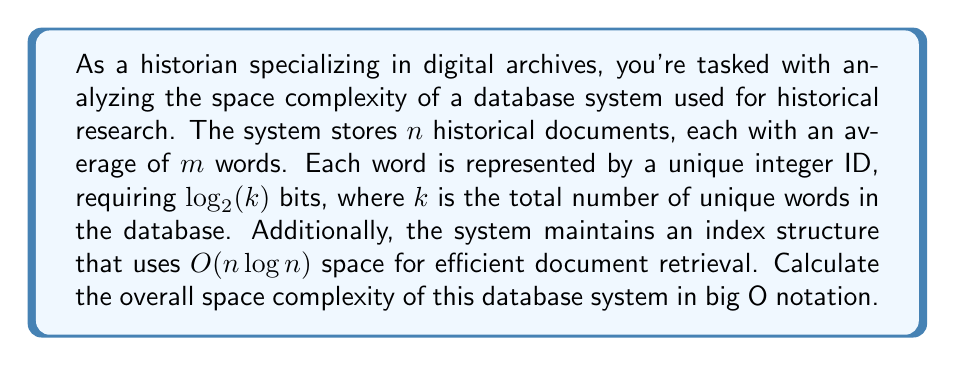Can you solve this math problem? Let's break down the space complexity analysis step by step:

1) Storage for documents:
   - Number of documents: $n$
   - Average words per document: $m$
   - Bits per word: $\log_2(k)$
   - Total space for documents: $O(n \cdot m \cdot \log_2(k))$

2) Index structure:
   - Space complexity: $O(n \log n)$

3) Combining the space requirements:
   The total space complexity is the sum of document storage and index structure:
   $$O(n \cdot m \cdot \log_2(k) + n \log n)$$

4) Simplifying the expression:
   - Since $m$ and $k$ are typically much smaller than $n$ in large databases, we can consider them as constants.
   - $\log_2(k)$ is also typically much smaller than $\log n$ for large $n$.
   
5) Final simplification:
   The dominant term will be $n \log n$, so we can express the overall space complexity as:
   $$O(n \log n)$$

This represents the asymptotic upper bound on the space required by the database system as the number of documents ($n$) grows large.
Answer: $O(n \log n)$ 